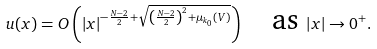<formula> <loc_0><loc_0><loc_500><loc_500>u ( x ) = O \left ( | x | ^ { - \frac { N - 2 } 2 + \sqrt { \left ( \frac { N - 2 } 2 \right ) ^ { 2 } + \mu _ { k _ { 0 } } ( V ) } } \right ) \quad \text {as } | x | \to 0 ^ { + } .</formula> 